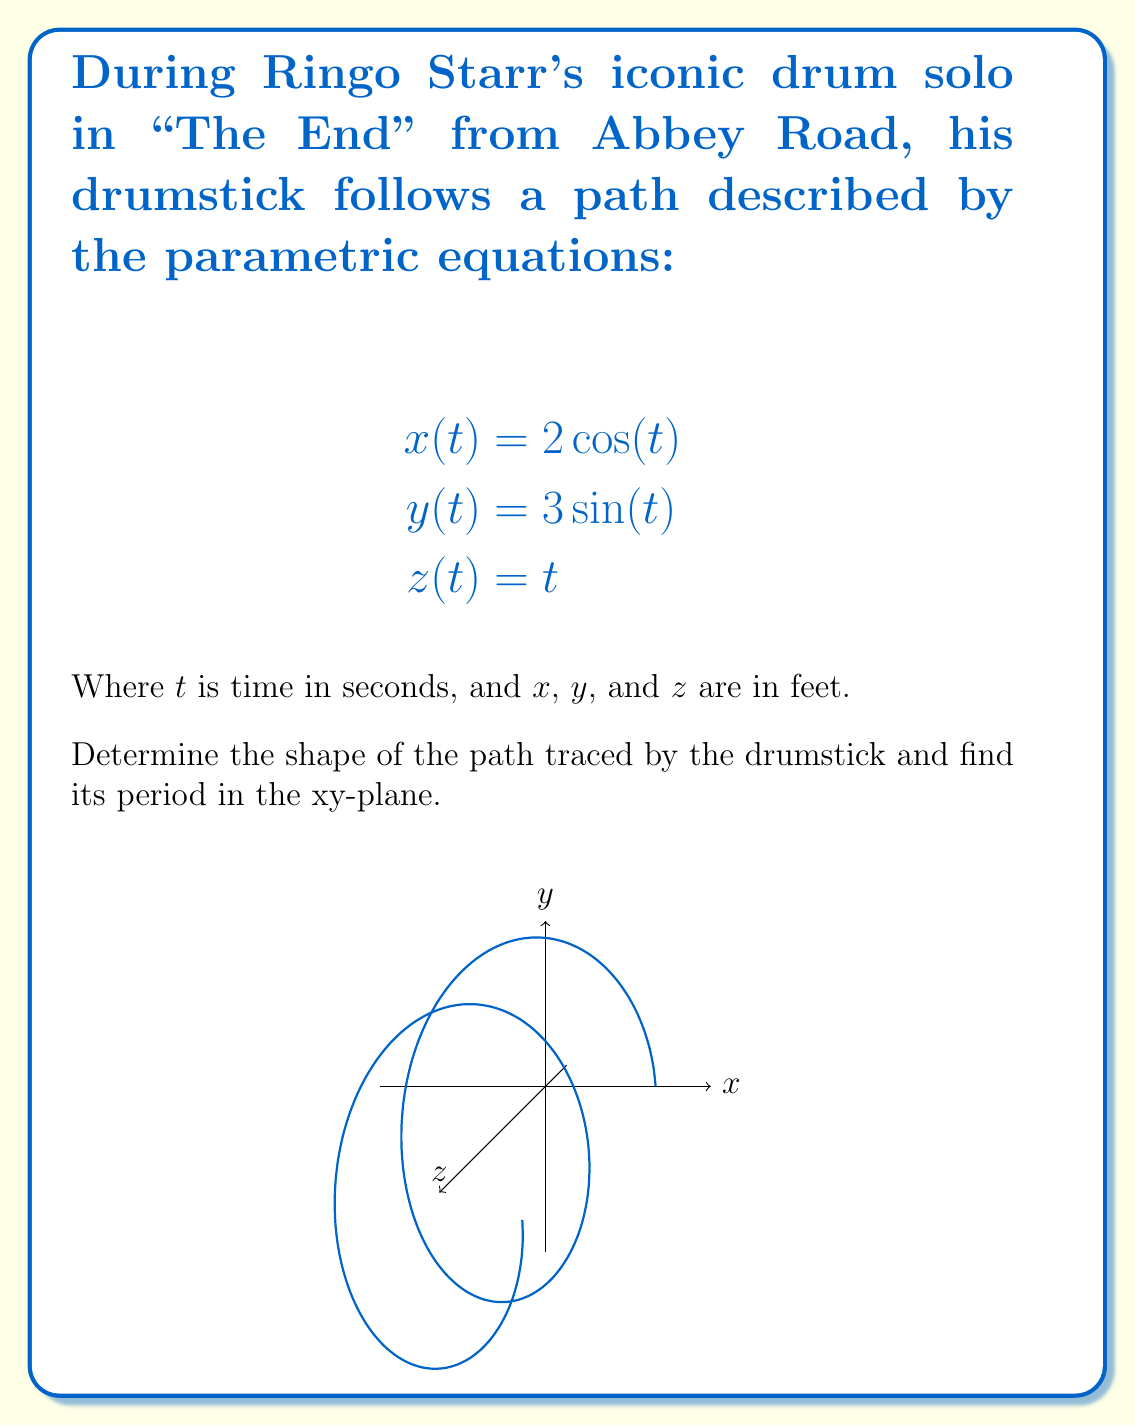Could you help me with this problem? Let's approach this step-by-step:

1) First, let's consider the equations in the xy-plane:
   $$x = 2\cos(t)$$
   $$y = 3\sin(t)$$

2) This is the standard form of parametric equations for an ellipse. The general form is:
   $$x = a\cos(t)$$
   $$y = b\sin(t)$$

3) In our case, $a = 2$ and $b = 3$. This means the ellipse has a horizontal semi-axis of 2 and a vertical semi-axis of 3.

4) To find the period in the xy-plane, we need to determine how long it takes for the point to complete one full rotation. This occurs when $t$ increases by $2\pi$.

5) However, the z-coordinate is given by $z = t$. This means that as the point rotates in the xy-plane, it's also rising linearly with time.

6) Combining these observations, we can conclude that the path of the drumstick forms a helical shape around an elliptical cylinder.

7) The period in the xy-plane is $2\pi$ seconds, as this is how long it takes for both $\cos(t)$ and $\sin(t)$ to complete one full cycle.
Answer: Elliptical helix; Period: $2\pi$ seconds 